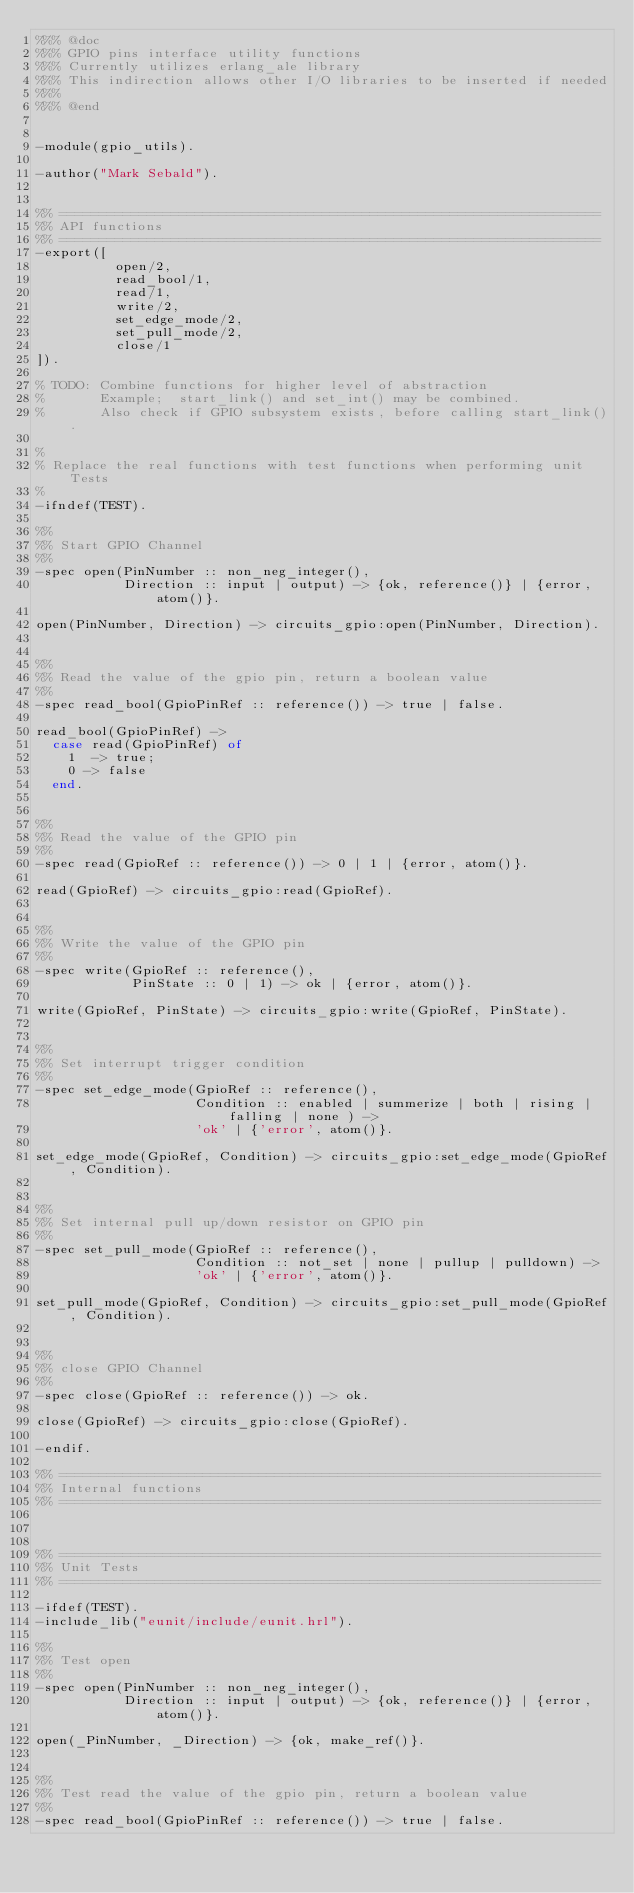<code> <loc_0><loc_0><loc_500><loc_500><_Erlang_>%%% @doc 
%%% GPIO pins interface utility functions 
%%% Currently utilizes erlang_ale library
%%% This indirection allows other I/O libraries to be inserted if needed
%%%               
%%% @end 


-module(gpio_utils).

-author("Mark Sebald").


%% ====================================================================
%% API functions
%% ====================================================================
-export([
          open/2,
          read_bool/1,
          read/1,
          write/2,
          set_edge_mode/2,
          set_pull_mode/2,
          close/1
]).

% TODO: Combine functions for higher level of abstraction
%       Example;  start_link() and set_int() may be combined.
%       Also check if GPIO subsystem exists, before calling start_link().

%
% Replace the real functions with test functions when performing unit Tests
%
-ifndef(TEST).

%%
%% Start GPIO Channel
%%
-spec open(PinNumber :: non_neg_integer(),
           Direction :: input | output) -> {ok, reference()} | {error, atom()}.

open(PinNumber, Direction) -> circuits_gpio:open(PinNumber, Direction).
 

%%
%% Read the value of the gpio pin, return a boolean value
%%
-spec read_bool(GpioPinRef :: reference()) -> true | false.

read_bool(GpioPinRef) ->
  case read(GpioPinRef) of
    1  -> true;
    0 -> false
  end.


%%
%% Read the value of the GPIO pin
%%
-spec read(GpioRef :: reference()) -> 0 | 1 | {error, atom()}.

read(GpioRef) -> circuits_gpio:read(GpioRef).


%%
%% Write the value of the GPIO pin
%%
-spec write(GpioRef :: reference(),
            PinState :: 0 | 1) -> ok | {error, atom()}.

write(GpioRef, PinState) -> circuits_gpio:write(GpioRef, PinState).


%%
%% Set interrupt trigger condition
%%
-spec set_edge_mode(GpioRef :: reference(),
                    Condition :: enabled | summerize | both | rising | falling | none ) -> 
                    'ok' | {'error', atom()}.

set_edge_mode(GpioRef, Condition) -> circuits_gpio:set_edge_mode(GpioRef, Condition).


%%
%% Set internal pull up/down resistor on GPIO pin
%%
-spec set_pull_mode(GpioRef :: reference(),
                    Condition :: not_set | none | pullup | pulldown) -> 
                    'ok' | {'error', atom()}.

set_pull_mode(GpioRef, Condition) -> circuits_gpio:set_pull_mode(GpioRef, Condition).


%%
%% close GPIO Channel
%%
-spec close(GpioRef :: reference()) -> ok. 

close(GpioRef) -> circuits_gpio:close(GpioRef).

-endif.

%% ====================================================================
%% Internal functions
%% ====================================================================



%% ====================================================================
%% Unit Tests
%% ====================================================================

-ifdef(TEST).
-include_lib("eunit/include/eunit.hrl").

%%
%% Test open
%%
-spec open(PinNumber :: non_neg_integer(),
           Direction :: input | output) -> {ok, reference()} | {error, atom()}.

open(_PinNumber, _Direction) -> {ok, make_ref()}.


%%
%% Test read the value of the gpio pin, return a boolean value
%%
-spec read_bool(GpioPinRef :: reference()) -> true | false.
</code> 